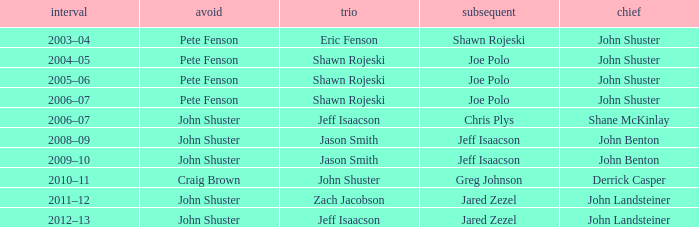Who was the lead with John Shuster as skip, Chris Plys in second, and Jeff Isaacson in third? Shane McKinlay. 